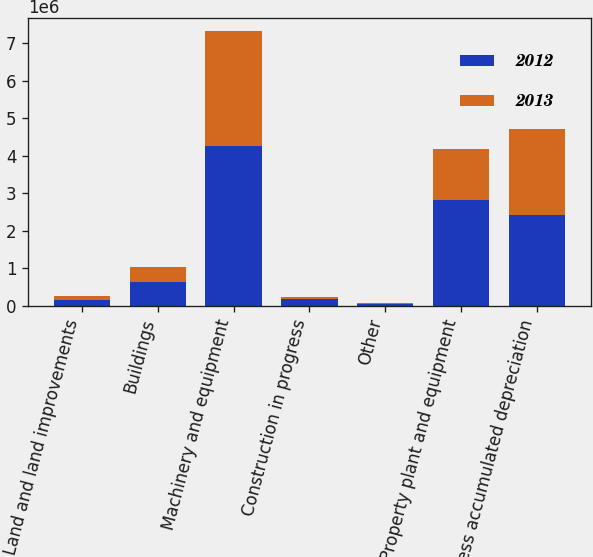Convert chart. <chart><loc_0><loc_0><loc_500><loc_500><stacked_bar_chart><ecel><fcel>Land and land improvements<fcel>Buildings<fcel>Machinery and equipment<fcel>Construction in progress<fcel>Other<fcel>Property plant and equipment<fcel>Less accumulated depreciation<nl><fcel>2012<fcel>140592<fcel>628948<fcel>4.2635e+06<fcel>168808<fcel>30847<fcel>2.8057e+06<fcel>2.427e+06<nl><fcel>2013<fcel>107250<fcel>390363<fcel>3.04893e+06<fcel>67051<fcel>27196<fcel>1.36607e+06<fcel>2.27472e+06<nl></chart> 